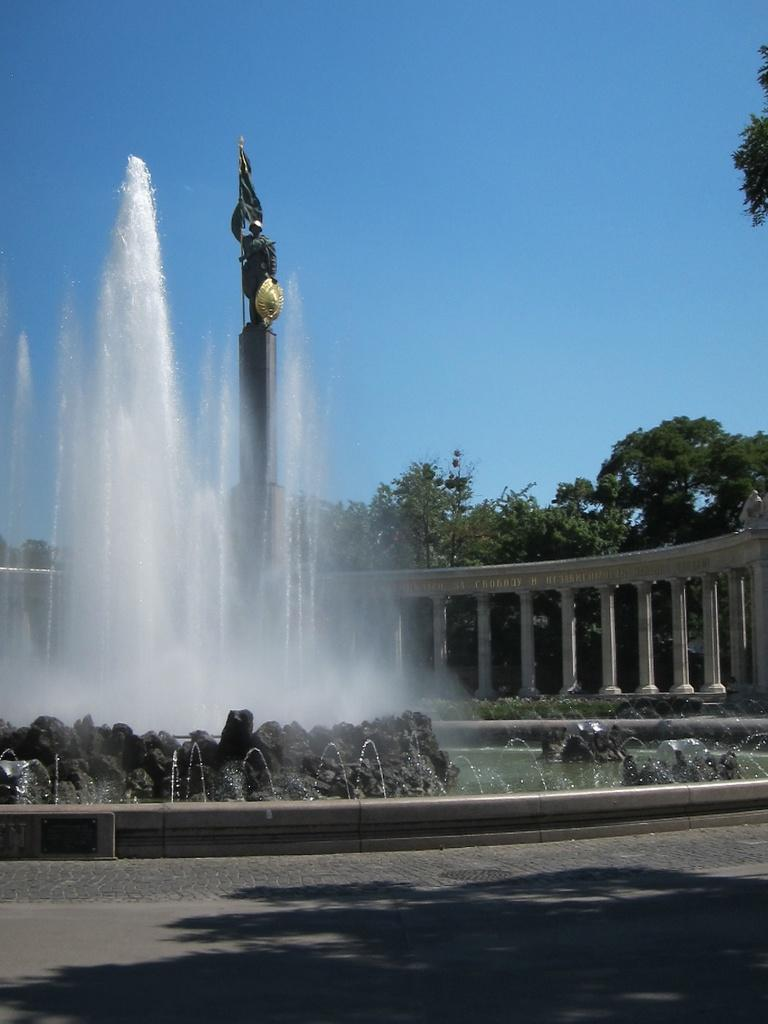What can be seen on the road in the image? There is a shadow on the road in the image. What is located in the background of the image? There is a water fountain, a sculpture, multiple pillars, and multiple trees in the background of the image. What part of the natural environment is visible in the image? The sky is visible in the background of the image. What type of lead can be seen in the jar on the sculpture in the image? There is no jar or lead present on the sculpture in the image. What type of flower is growing near the water fountain in the image? There are no flowers visible near the water fountain in the image. 